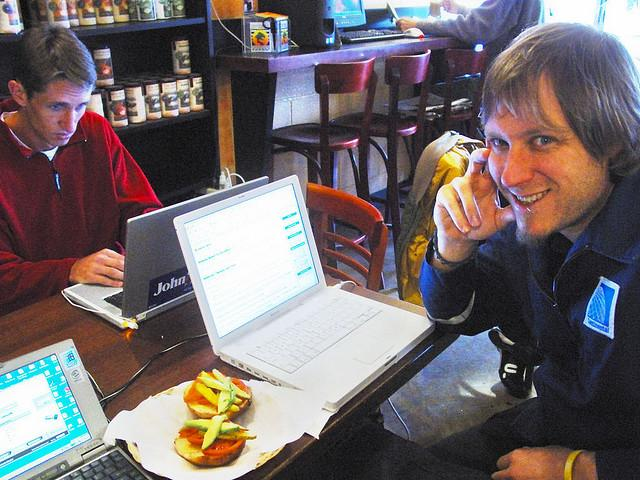What are the green items on top of the tomatoes on the man's sandwich? avocado 